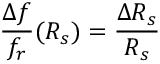<formula> <loc_0><loc_0><loc_500><loc_500>\frac { \Delta f } { f _ { r } } ( R _ { s } ) = \frac { \Delta R _ { s } } { R _ { s } }</formula> 